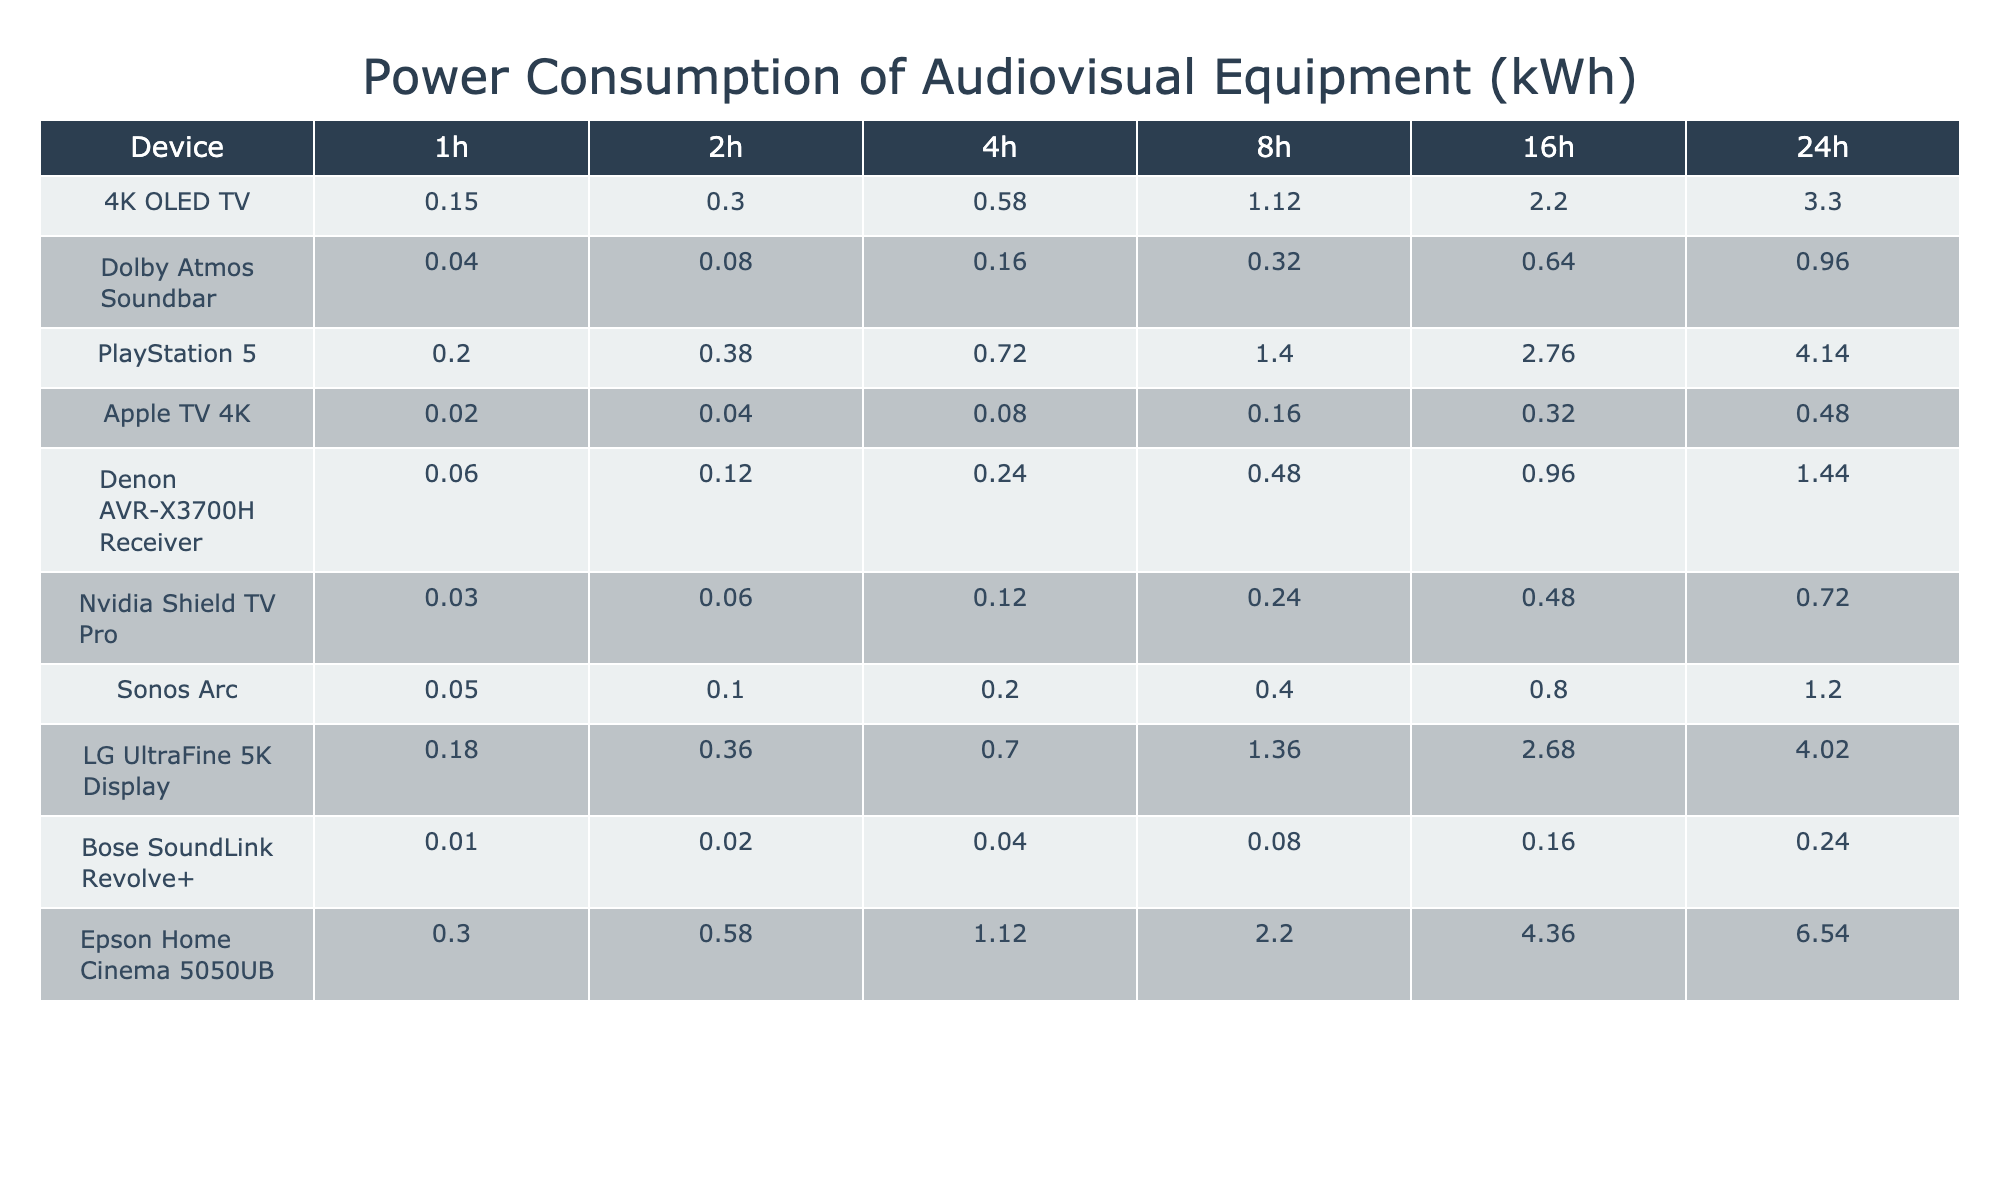What is the power consumption of the 4K OLED TV over 16 hours? The table shows the power consumption of the 4K OLED TV for different time intervals. For 16 hours, the corresponding value is listed as 2.20 kWh.
Answer: 2.20 kWh Which device consumes the least power over 1 hour? By examining the first column of the table for 1 hour, the device with the lowest value is the Bose SoundLink Revolve+, which has a consumption of 0.01 kWh.
Answer: Bose SoundLink Revolve+ What is the total power consumption of the PlayStation 5 and the Denon AVR-X3700H Receiver over 24 hours? The total power consumption over 24 hours for the PlayStation 5 is 4.14 kWh and for the Denon AVR-X3700H Receiver it’s 1.44 kWh. Adding these two gives 4.14 + 1.44 = 5.58 kWh.
Answer: 5.58 kWh What is the average power consumption of the Dolby Atmos Soundbar over the duration of 24 hours? The 24-hour consumption of the Dolby Atmos Soundbar is 0.96 kWh. Since there's only one data point for 24 hours, the average is simply that value.
Answer: 0.96 kWh How much more power does the Epson Home Cinema 5050UB consume over 8 hours compared to the Apple TV 4K? The Epson Home Cinema 5050UB consumes 2.20 kWh over 8 hours, while the Apple TV 4K consumes 0.16 kWh. The difference is 2.20 - 0.16 = 2.04 kWh.
Answer: 2.04 kWh Is the total power consumption of the LG UltraFine 5K Display higher than that of the 4K OLED TV over 4 hours? The LG UltraFine 5K Display consumes 0.70 kWh over 4 hours, while the 4K OLED TV consumes 0.58 kWh. Since 0.70 is greater than 0.58, the statement is true.
Answer: Yes What is the total power consumption of all devices over 2 hours? By summing the 2-hour values from each device in the table: 0.30 (4K OLED TV) + 0.08 (Dolby Atmos Soundbar) + 0.38 (PlayStation 5) + 0.04 (Apple TV 4K) + 0.12 (Denon AVR-X3700H Receiver) + 0.06 (Nvidia Shield TV Pro) + 0.10 (Sonos Arc) + 0.36 (LG UltraFine 5K Display) + 0.02 (Bose SoundLink Revolve+) + 0.58 (Epson Home Cinema 5050UB) = 1.68 kWh total.
Answer: 1.68 kWh What is the difference in power consumption over 24 hours between the Nvidia Shield TV Pro and the Sonos Arc? The Nvidia Shield TV Pro consumes 0.72 kWh and the Sonos Arc consumes 1.20 kWh over 24 hours. The difference is calculated as 1.20 - 0.72 = 0.48 kWh.
Answer: 0.48 kWh Which device has the highest power consumption after 16 hours? The highest value in the 16-hour column must be identified. After checking the values, the device with the highest consumption is the PlayStation 5 at 2.76 kWh.
Answer: PlayStation 5 Is the total power consumption of any two devices over 1 hour equal to 0.20 kWh? Checking possible pairs among devices, the sum of the 4K OLED TV (0.15 kWh) and the Bose SoundLink Revolve+ (0.01 kWh) equals 0.16 kWh, while none of the pairs sum to 0.20 kWh. Therefore, the statement is false.
Answer: No 